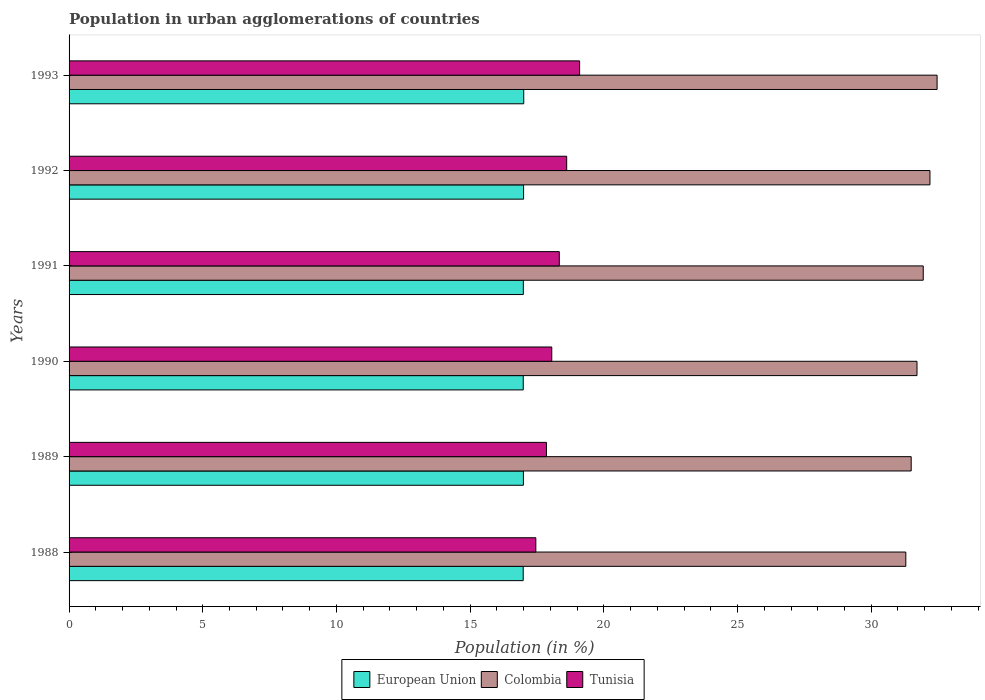How many groups of bars are there?
Give a very brief answer. 6. Are the number of bars on each tick of the Y-axis equal?
Offer a very short reply. Yes. How many bars are there on the 3rd tick from the top?
Keep it short and to the point. 3. How many bars are there on the 5th tick from the bottom?
Ensure brevity in your answer.  3. What is the label of the 5th group of bars from the top?
Give a very brief answer. 1989. What is the percentage of population in urban agglomerations in Colombia in 1988?
Make the answer very short. 31.29. Across all years, what is the maximum percentage of population in urban agglomerations in European Union?
Your answer should be very brief. 17. Across all years, what is the minimum percentage of population in urban agglomerations in Tunisia?
Offer a very short reply. 17.46. In which year was the percentage of population in urban agglomerations in Colombia maximum?
Your answer should be compact. 1993. In which year was the percentage of population in urban agglomerations in European Union minimum?
Make the answer very short. 1988. What is the total percentage of population in urban agglomerations in Tunisia in the graph?
Your response must be concise. 109.4. What is the difference between the percentage of population in urban agglomerations in Tunisia in 1988 and that in 1992?
Give a very brief answer. -1.15. What is the difference between the percentage of population in urban agglomerations in Tunisia in 1990 and the percentage of population in urban agglomerations in European Union in 1988?
Provide a succinct answer. 1.07. What is the average percentage of population in urban agglomerations in Tunisia per year?
Your response must be concise. 18.23. In the year 1988, what is the difference between the percentage of population in urban agglomerations in Tunisia and percentage of population in urban agglomerations in European Union?
Your response must be concise. 0.47. What is the ratio of the percentage of population in urban agglomerations in Colombia in 1989 to that in 1992?
Give a very brief answer. 0.98. Is the percentage of population in urban agglomerations in European Union in 1989 less than that in 1993?
Offer a very short reply. Yes. Is the difference between the percentage of population in urban agglomerations in Tunisia in 1988 and 1993 greater than the difference between the percentage of population in urban agglomerations in European Union in 1988 and 1993?
Give a very brief answer. No. What is the difference between the highest and the second highest percentage of population in urban agglomerations in Tunisia?
Give a very brief answer. 0.48. What is the difference between the highest and the lowest percentage of population in urban agglomerations in Tunisia?
Offer a very short reply. 1.64. What does the 3rd bar from the top in 1990 represents?
Ensure brevity in your answer.  European Union. What does the 3rd bar from the bottom in 1991 represents?
Give a very brief answer. Tunisia. Are all the bars in the graph horizontal?
Make the answer very short. Yes. Are the values on the major ticks of X-axis written in scientific E-notation?
Make the answer very short. No. Does the graph contain any zero values?
Make the answer very short. No. Does the graph contain grids?
Offer a very short reply. No. How many legend labels are there?
Your answer should be very brief. 3. How are the legend labels stacked?
Your answer should be compact. Horizontal. What is the title of the graph?
Provide a short and direct response. Population in urban agglomerations of countries. What is the label or title of the X-axis?
Offer a very short reply. Population (in %). What is the Population (in %) of European Union in 1988?
Offer a terse response. 16.98. What is the Population (in %) of Colombia in 1988?
Make the answer very short. 31.29. What is the Population (in %) in Tunisia in 1988?
Give a very brief answer. 17.46. What is the Population (in %) in European Union in 1989?
Your answer should be very brief. 16.99. What is the Population (in %) in Colombia in 1989?
Keep it short and to the point. 31.49. What is the Population (in %) of Tunisia in 1989?
Your response must be concise. 17.85. What is the Population (in %) of European Union in 1990?
Ensure brevity in your answer.  16.99. What is the Population (in %) in Colombia in 1990?
Keep it short and to the point. 31.71. What is the Population (in %) in Tunisia in 1990?
Your answer should be compact. 18.05. What is the Population (in %) in European Union in 1991?
Provide a succinct answer. 16.99. What is the Population (in %) in Colombia in 1991?
Give a very brief answer. 31.95. What is the Population (in %) of Tunisia in 1991?
Your answer should be compact. 18.33. What is the Population (in %) of European Union in 1992?
Keep it short and to the point. 17. What is the Population (in %) of Colombia in 1992?
Ensure brevity in your answer.  32.2. What is the Population (in %) in Tunisia in 1992?
Make the answer very short. 18.61. What is the Population (in %) of European Union in 1993?
Provide a short and direct response. 17. What is the Population (in %) of Colombia in 1993?
Your response must be concise. 32.46. What is the Population (in %) in Tunisia in 1993?
Offer a terse response. 19.09. Across all years, what is the maximum Population (in %) of European Union?
Provide a succinct answer. 17. Across all years, what is the maximum Population (in %) of Colombia?
Ensure brevity in your answer.  32.46. Across all years, what is the maximum Population (in %) in Tunisia?
Provide a succinct answer. 19.09. Across all years, what is the minimum Population (in %) in European Union?
Provide a short and direct response. 16.98. Across all years, what is the minimum Population (in %) in Colombia?
Your answer should be very brief. 31.29. Across all years, what is the minimum Population (in %) in Tunisia?
Keep it short and to the point. 17.46. What is the total Population (in %) of European Union in the graph?
Offer a terse response. 101.96. What is the total Population (in %) of Colombia in the graph?
Give a very brief answer. 191.11. What is the total Population (in %) of Tunisia in the graph?
Your response must be concise. 109.4. What is the difference between the Population (in %) in European Union in 1988 and that in 1989?
Your answer should be compact. -0.01. What is the difference between the Population (in %) in Colombia in 1988 and that in 1989?
Keep it short and to the point. -0.2. What is the difference between the Population (in %) in Tunisia in 1988 and that in 1989?
Your answer should be compact. -0.4. What is the difference between the Population (in %) of European Union in 1988 and that in 1990?
Provide a short and direct response. -0. What is the difference between the Population (in %) in Colombia in 1988 and that in 1990?
Offer a very short reply. -0.42. What is the difference between the Population (in %) in Tunisia in 1988 and that in 1990?
Ensure brevity in your answer.  -0.6. What is the difference between the Population (in %) in European Union in 1988 and that in 1991?
Your answer should be very brief. -0. What is the difference between the Population (in %) in Colombia in 1988 and that in 1991?
Offer a terse response. -0.65. What is the difference between the Population (in %) in Tunisia in 1988 and that in 1991?
Your answer should be very brief. -0.88. What is the difference between the Population (in %) of European Union in 1988 and that in 1992?
Make the answer very short. -0.01. What is the difference between the Population (in %) in Colombia in 1988 and that in 1992?
Your response must be concise. -0.9. What is the difference between the Population (in %) in Tunisia in 1988 and that in 1992?
Provide a succinct answer. -1.15. What is the difference between the Population (in %) of European Union in 1988 and that in 1993?
Make the answer very short. -0.02. What is the difference between the Population (in %) in Colombia in 1988 and that in 1993?
Ensure brevity in your answer.  -1.17. What is the difference between the Population (in %) of Tunisia in 1988 and that in 1993?
Make the answer very short. -1.64. What is the difference between the Population (in %) of European Union in 1989 and that in 1990?
Give a very brief answer. 0.01. What is the difference between the Population (in %) of Colombia in 1989 and that in 1990?
Provide a succinct answer. -0.22. What is the difference between the Population (in %) in Tunisia in 1989 and that in 1990?
Provide a succinct answer. -0.2. What is the difference between the Population (in %) in European Union in 1989 and that in 1991?
Your answer should be very brief. 0. What is the difference between the Population (in %) of Colombia in 1989 and that in 1991?
Ensure brevity in your answer.  -0.45. What is the difference between the Population (in %) in Tunisia in 1989 and that in 1991?
Offer a very short reply. -0.48. What is the difference between the Population (in %) in European Union in 1989 and that in 1992?
Give a very brief answer. -0.01. What is the difference between the Population (in %) of Colombia in 1989 and that in 1992?
Your response must be concise. -0.7. What is the difference between the Population (in %) in Tunisia in 1989 and that in 1992?
Your answer should be compact. -0.76. What is the difference between the Population (in %) in European Union in 1989 and that in 1993?
Offer a very short reply. -0.01. What is the difference between the Population (in %) of Colombia in 1989 and that in 1993?
Ensure brevity in your answer.  -0.97. What is the difference between the Population (in %) in Tunisia in 1989 and that in 1993?
Offer a terse response. -1.24. What is the difference between the Population (in %) of European Union in 1990 and that in 1991?
Make the answer very short. -0. What is the difference between the Population (in %) of Colombia in 1990 and that in 1991?
Offer a very short reply. -0.23. What is the difference between the Population (in %) in Tunisia in 1990 and that in 1991?
Provide a succinct answer. -0.28. What is the difference between the Population (in %) in European Union in 1990 and that in 1992?
Offer a terse response. -0.01. What is the difference between the Population (in %) in Colombia in 1990 and that in 1992?
Provide a succinct answer. -0.48. What is the difference between the Population (in %) in Tunisia in 1990 and that in 1992?
Your answer should be very brief. -0.56. What is the difference between the Population (in %) of European Union in 1990 and that in 1993?
Provide a short and direct response. -0.02. What is the difference between the Population (in %) in Colombia in 1990 and that in 1993?
Offer a terse response. -0.75. What is the difference between the Population (in %) of Tunisia in 1990 and that in 1993?
Provide a succinct answer. -1.04. What is the difference between the Population (in %) of European Union in 1991 and that in 1992?
Keep it short and to the point. -0.01. What is the difference between the Population (in %) in Colombia in 1991 and that in 1992?
Keep it short and to the point. -0.25. What is the difference between the Population (in %) in Tunisia in 1991 and that in 1992?
Your response must be concise. -0.28. What is the difference between the Population (in %) of European Union in 1991 and that in 1993?
Ensure brevity in your answer.  -0.02. What is the difference between the Population (in %) in Colombia in 1991 and that in 1993?
Your answer should be very brief. -0.52. What is the difference between the Population (in %) in Tunisia in 1991 and that in 1993?
Your response must be concise. -0.76. What is the difference between the Population (in %) in European Union in 1992 and that in 1993?
Your response must be concise. -0.01. What is the difference between the Population (in %) of Colombia in 1992 and that in 1993?
Provide a succinct answer. -0.27. What is the difference between the Population (in %) in Tunisia in 1992 and that in 1993?
Your response must be concise. -0.48. What is the difference between the Population (in %) of European Union in 1988 and the Population (in %) of Colombia in 1989?
Offer a very short reply. -14.51. What is the difference between the Population (in %) in European Union in 1988 and the Population (in %) in Tunisia in 1989?
Provide a short and direct response. -0.87. What is the difference between the Population (in %) in Colombia in 1988 and the Population (in %) in Tunisia in 1989?
Provide a succinct answer. 13.44. What is the difference between the Population (in %) of European Union in 1988 and the Population (in %) of Colombia in 1990?
Give a very brief answer. -14.73. What is the difference between the Population (in %) of European Union in 1988 and the Population (in %) of Tunisia in 1990?
Give a very brief answer. -1.07. What is the difference between the Population (in %) in Colombia in 1988 and the Population (in %) in Tunisia in 1990?
Your response must be concise. 13.24. What is the difference between the Population (in %) of European Union in 1988 and the Population (in %) of Colombia in 1991?
Keep it short and to the point. -14.96. What is the difference between the Population (in %) of European Union in 1988 and the Population (in %) of Tunisia in 1991?
Make the answer very short. -1.35. What is the difference between the Population (in %) of Colombia in 1988 and the Population (in %) of Tunisia in 1991?
Offer a terse response. 12.96. What is the difference between the Population (in %) in European Union in 1988 and the Population (in %) in Colombia in 1992?
Provide a short and direct response. -15.21. What is the difference between the Population (in %) of European Union in 1988 and the Population (in %) of Tunisia in 1992?
Provide a short and direct response. -1.63. What is the difference between the Population (in %) in Colombia in 1988 and the Population (in %) in Tunisia in 1992?
Your answer should be very brief. 12.68. What is the difference between the Population (in %) of European Union in 1988 and the Population (in %) of Colombia in 1993?
Your response must be concise. -15.48. What is the difference between the Population (in %) in European Union in 1988 and the Population (in %) in Tunisia in 1993?
Your answer should be compact. -2.11. What is the difference between the Population (in %) of Colombia in 1988 and the Population (in %) of Tunisia in 1993?
Keep it short and to the point. 12.2. What is the difference between the Population (in %) in European Union in 1989 and the Population (in %) in Colombia in 1990?
Provide a succinct answer. -14.72. What is the difference between the Population (in %) of European Union in 1989 and the Population (in %) of Tunisia in 1990?
Give a very brief answer. -1.06. What is the difference between the Population (in %) of Colombia in 1989 and the Population (in %) of Tunisia in 1990?
Provide a short and direct response. 13.44. What is the difference between the Population (in %) in European Union in 1989 and the Population (in %) in Colombia in 1991?
Provide a succinct answer. -14.95. What is the difference between the Population (in %) in European Union in 1989 and the Population (in %) in Tunisia in 1991?
Offer a very short reply. -1.34. What is the difference between the Population (in %) of Colombia in 1989 and the Population (in %) of Tunisia in 1991?
Give a very brief answer. 13.16. What is the difference between the Population (in %) in European Union in 1989 and the Population (in %) in Colombia in 1992?
Offer a terse response. -15.2. What is the difference between the Population (in %) in European Union in 1989 and the Population (in %) in Tunisia in 1992?
Offer a very short reply. -1.62. What is the difference between the Population (in %) of Colombia in 1989 and the Population (in %) of Tunisia in 1992?
Provide a succinct answer. 12.88. What is the difference between the Population (in %) in European Union in 1989 and the Population (in %) in Colombia in 1993?
Provide a succinct answer. -15.47. What is the difference between the Population (in %) of European Union in 1989 and the Population (in %) of Tunisia in 1993?
Make the answer very short. -2.1. What is the difference between the Population (in %) of European Union in 1990 and the Population (in %) of Colombia in 1991?
Offer a very short reply. -14.96. What is the difference between the Population (in %) in European Union in 1990 and the Population (in %) in Tunisia in 1991?
Give a very brief answer. -1.35. What is the difference between the Population (in %) in Colombia in 1990 and the Population (in %) in Tunisia in 1991?
Offer a very short reply. 13.38. What is the difference between the Population (in %) in European Union in 1990 and the Population (in %) in Colombia in 1992?
Provide a short and direct response. -15.21. What is the difference between the Population (in %) in European Union in 1990 and the Population (in %) in Tunisia in 1992?
Your answer should be very brief. -1.62. What is the difference between the Population (in %) in Colombia in 1990 and the Population (in %) in Tunisia in 1992?
Make the answer very short. 13.1. What is the difference between the Population (in %) of European Union in 1990 and the Population (in %) of Colombia in 1993?
Your response must be concise. -15.48. What is the difference between the Population (in %) of European Union in 1990 and the Population (in %) of Tunisia in 1993?
Provide a short and direct response. -2.11. What is the difference between the Population (in %) in Colombia in 1990 and the Population (in %) in Tunisia in 1993?
Your response must be concise. 12.62. What is the difference between the Population (in %) in European Union in 1991 and the Population (in %) in Colombia in 1992?
Provide a succinct answer. -15.21. What is the difference between the Population (in %) of European Union in 1991 and the Population (in %) of Tunisia in 1992?
Ensure brevity in your answer.  -1.62. What is the difference between the Population (in %) in Colombia in 1991 and the Population (in %) in Tunisia in 1992?
Keep it short and to the point. 13.33. What is the difference between the Population (in %) in European Union in 1991 and the Population (in %) in Colombia in 1993?
Give a very brief answer. -15.47. What is the difference between the Population (in %) of European Union in 1991 and the Population (in %) of Tunisia in 1993?
Ensure brevity in your answer.  -2.11. What is the difference between the Population (in %) of Colombia in 1991 and the Population (in %) of Tunisia in 1993?
Ensure brevity in your answer.  12.85. What is the difference between the Population (in %) of European Union in 1992 and the Population (in %) of Colombia in 1993?
Your answer should be very brief. -15.46. What is the difference between the Population (in %) in European Union in 1992 and the Population (in %) in Tunisia in 1993?
Your answer should be compact. -2.1. What is the difference between the Population (in %) of Colombia in 1992 and the Population (in %) of Tunisia in 1993?
Provide a succinct answer. 13.1. What is the average Population (in %) of European Union per year?
Keep it short and to the point. 16.99. What is the average Population (in %) of Colombia per year?
Your answer should be compact. 31.85. What is the average Population (in %) of Tunisia per year?
Ensure brevity in your answer.  18.23. In the year 1988, what is the difference between the Population (in %) in European Union and Population (in %) in Colombia?
Offer a terse response. -14.31. In the year 1988, what is the difference between the Population (in %) of European Union and Population (in %) of Tunisia?
Provide a succinct answer. -0.47. In the year 1988, what is the difference between the Population (in %) in Colombia and Population (in %) in Tunisia?
Offer a very short reply. 13.84. In the year 1989, what is the difference between the Population (in %) of European Union and Population (in %) of Colombia?
Ensure brevity in your answer.  -14.5. In the year 1989, what is the difference between the Population (in %) of European Union and Population (in %) of Tunisia?
Offer a very short reply. -0.86. In the year 1989, what is the difference between the Population (in %) in Colombia and Population (in %) in Tunisia?
Your response must be concise. 13.64. In the year 1990, what is the difference between the Population (in %) in European Union and Population (in %) in Colombia?
Your answer should be compact. -14.73. In the year 1990, what is the difference between the Population (in %) in European Union and Population (in %) in Tunisia?
Offer a terse response. -1.07. In the year 1990, what is the difference between the Population (in %) in Colombia and Population (in %) in Tunisia?
Provide a short and direct response. 13.66. In the year 1991, what is the difference between the Population (in %) of European Union and Population (in %) of Colombia?
Your response must be concise. -14.96. In the year 1991, what is the difference between the Population (in %) in European Union and Population (in %) in Tunisia?
Ensure brevity in your answer.  -1.35. In the year 1991, what is the difference between the Population (in %) in Colombia and Population (in %) in Tunisia?
Make the answer very short. 13.61. In the year 1992, what is the difference between the Population (in %) of European Union and Population (in %) of Colombia?
Keep it short and to the point. -15.2. In the year 1992, what is the difference between the Population (in %) of European Union and Population (in %) of Tunisia?
Provide a succinct answer. -1.61. In the year 1992, what is the difference between the Population (in %) in Colombia and Population (in %) in Tunisia?
Your answer should be very brief. 13.59. In the year 1993, what is the difference between the Population (in %) of European Union and Population (in %) of Colombia?
Make the answer very short. -15.46. In the year 1993, what is the difference between the Population (in %) of European Union and Population (in %) of Tunisia?
Provide a succinct answer. -2.09. In the year 1993, what is the difference between the Population (in %) in Colombia and Population (in %) in Tunisia?
Your answer should be very brief. 13.37. What is the ratio of the Population (in %) of Colombia in 1988 to that in 1989?
Provide a short and direct response. 0.99. What is the ratio of the Population (in %) in Tunisia in 1988 to that in 1989?
Make the answer very short. 0.98. What is the ratio of the Population (in %) in European Union in 1988 to that in 1990?
Keep it short and to the point. 1. What is the ratio of the Population (in %) of Colombia in 1988 to that in 1991?
Your answer should be very brief. 0.98. What is the ratio of the Population (in %) of Tunisia in 1988 to that in 1991?
Provide a short and direct response. 0.95. What is the ratio of the Population (in %) in European Union in 1988 to that in 1992?
Provide a short and direct response. 1. What is the ratio of the Population (in %) of Colombia in 1988 to that in 1992?
Your answer should be very brief. 0.97. What is the ratio of the Population (in %) of Tunisia in 1988 to that in 1992?
Make the answer very short. 0.94. What is the ratio of the Population (in %) in Tunisia in 1988 to that in 1993?
Offer a very short reply. 0.91. What is the ratio of the Population (in %) of Tunisia in 1989 to that in 1990?
Your answer should be very brief. 0.99. What is the ratio of the Population (in %) of European Union in 1989 to that in 1991?
Keep it short and to the point. 1. What is the ratio of the Population (in %) of Colombia in 1989 to that in 1991?
Provide a succinct answer. 0.99. What is the ratio of the Population (in %) in Tunisia in 1989 to that in 1991?
Make the answer very short. 0.97. What is the ratio of the Population (in %) in European Union in 1989 to that in 1992?
Provide a succinct answer. 1. What is the ratio of the Population (in %) in Colombia in 1989 to that in 1992?
Keep it short and to the point. 0.98. What is the ratio of the Population (in %) of Tunisia in 1989 to that in 1992?
Your response must be concise. 0.96. What is the ratio of the Population (in %) of European Union in 1989 to that in 1993?
Give a very brief answer. 1. What is the ratio of the Population (in %) in Colombia in 1989 to that in 1993?
Your answer should be compact. 0.97. What is the ratio of the Population (in %) of Tunisia in 1989 to that in 1993?
Your response must be concise. 0.94. What is the ratio of the Population (in %) of Tunisia in 1990 to that in 1991?
Give a very brief answer. 0.98. What is the ratio of the Population (in %) in Colombia in 1990 to that in 1992?
Your answer should be compact. 0.98. What is the ratio of the Population (in %) of Colombia in 1990 to that in 1993?
Keep it short and to the point. 0.98. What is the ratio of the Population (in %) of Tunisia in 1990 to that in 1993?
Provide a succinct answer. 0.95. What is the ratio of the Population (in %) in European Union in 1991 to that in 1992?
Make the answer very short. 1. What is the ratio of the Population (in %) of Tunisia in 1991 to that in 1992?
Make the answer very short. 0.99. What is the ratio of the Population (in %) of Tunisia in 1991 to that in 1993?
Provide a succinct answer. 0.96. What is the ratio of the Population (in %) of European Union in 1992 to that in 1993?
Provide a short and direct response. 1. What is the ratio of the Population (in %) in Tunisia in 1992 to that in 1993?
Ensure brevity in your answer.  0.97. What is the difference between the highest and the second highest Population (in %) of European Union?
Your answer should be compact. 0.01. What is the difference between the highest and the second highest Population (in %) in Colombia?
Give a very brief answer. 0.27. What is the difference between the highest and the second highest Population (in %) in Tunisia?
Your response must be concise. 0.48. What is the difference between the highest and the lowest Population (in %) in European Union?
Make the answer very short. 0.02. What is the difference between the highest and the lowest Population (in %) in Colombia?
Make the answer very short. 1.17. What is the difference between the highest and the lowest Population (in %) of Tunisia?
Your answer should be very brief. 1.64. 